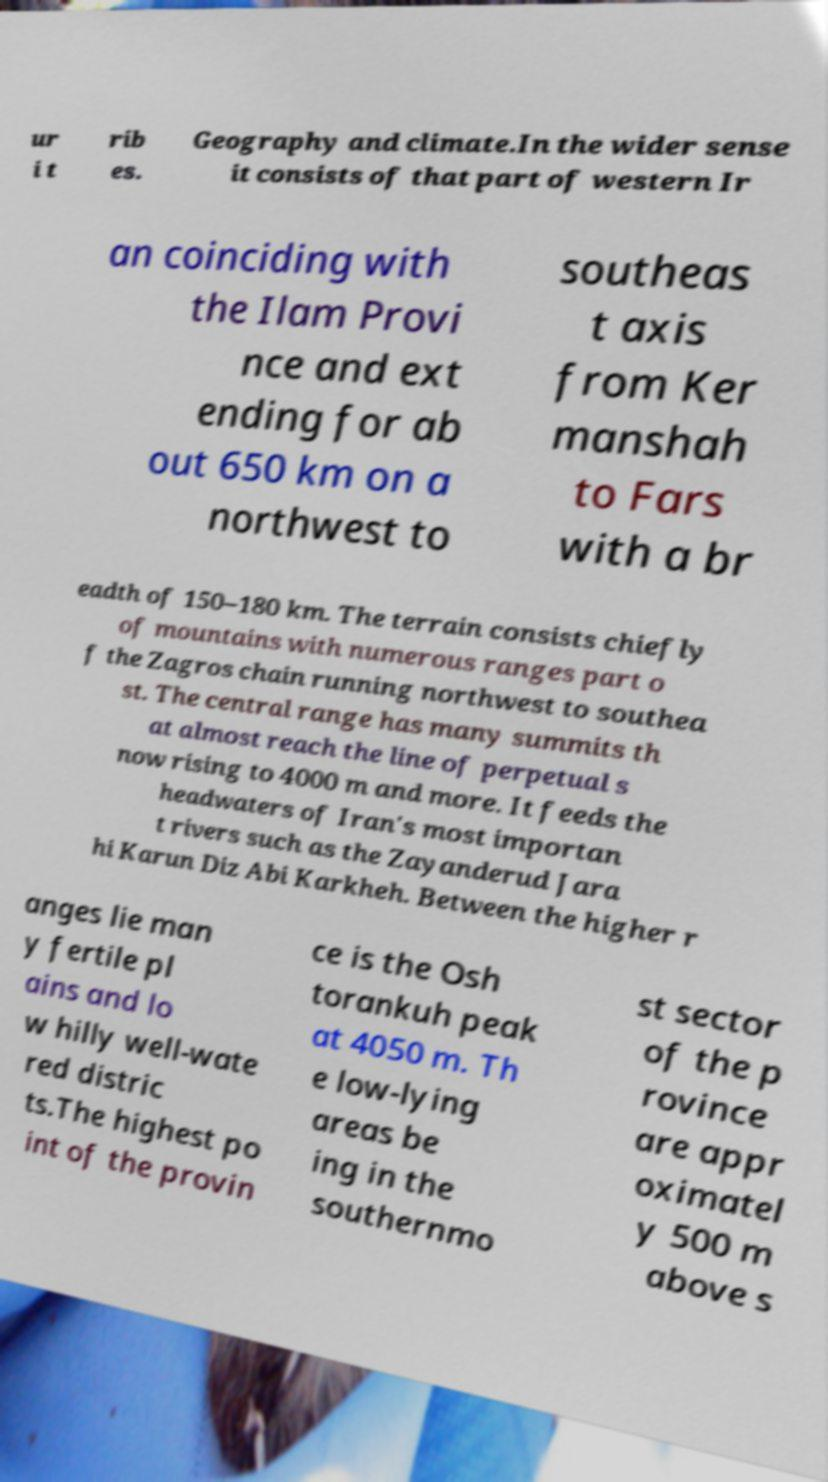Please identify and transcribe the text found in this image. ur i t rib es. Geography and climate.In the wider sense it consists of that part of western Ir an coinciding with the Ilam Provi nce and ext ending for ab out 650 km on a northwest to southeas t axis from Ker manshah to Fars with a br eadth of 150–180 km. The terrain consists chiefly of mountains with numerous ranges part o f the Zagros chain running northwest to southea st. The central range has many summits th at almost reach the line of perpetual s now rising to 4000 m and more. It feeds the headwaters of Iran's most importan t rivers such as the Zayanderud Jara hi Karun Diz Abi Karkheh. Between the higher r anges lie man y fertile pl ains and lo w hilly well-wate red distric ts.The highest po int of the provin ce is the Osh torankuh peak at 4050 m. Th e low-lying areas be ing in the southernmo st sector of the p rovince are appr oximatel y 500 m above s 